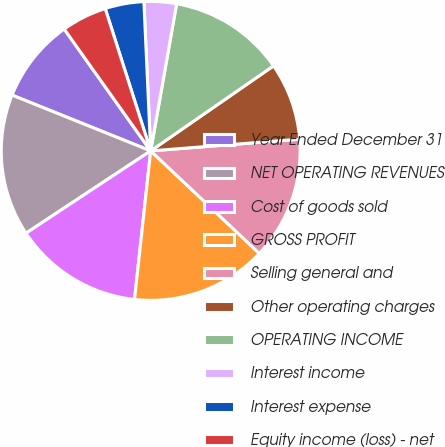Convert chart. <chart><loc_0><loc_0><loc_500><loc_500><pie_chart><fcel>Year Ended December 31<fcel>NET OPERATING REVENUES<fcel>Cost of goods sold<fcel>GROSS PROFIT<fcel>Selling general and<fcel>Other operating charges<fcel>OPERATING INCOME<fcel>Interest income<fcel>Interest expense<fcel>Equity income (loss) - net<nl><fcel>9.09%<fcel>15.38%<fcel>13.99%<fcel>14.69%<fcel>13.29%<fcel>8.39%<fcel>12.59%<fcel>3.5%<fcel>4.2%<fcel>4.9%<nl></chart> 